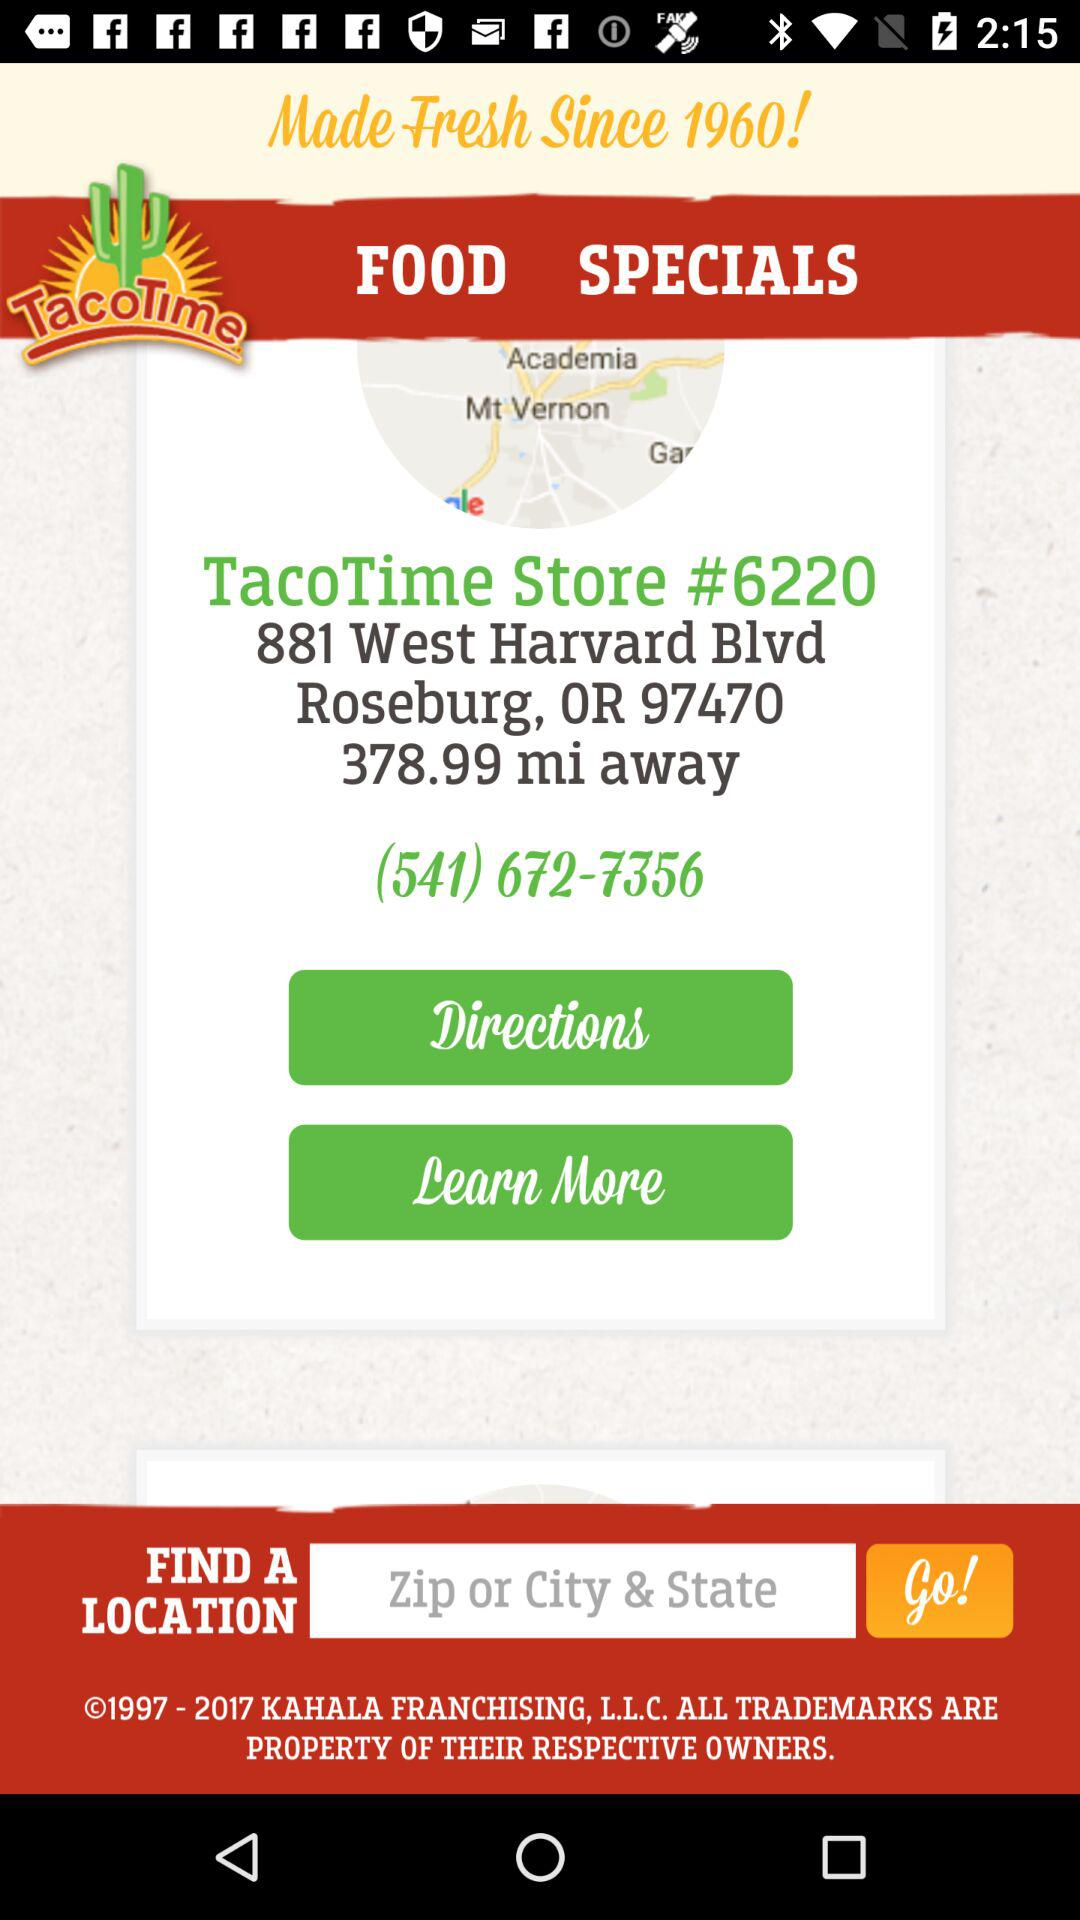What is the zip code of the store?
Answer the question using a single word or phrase. 97470 